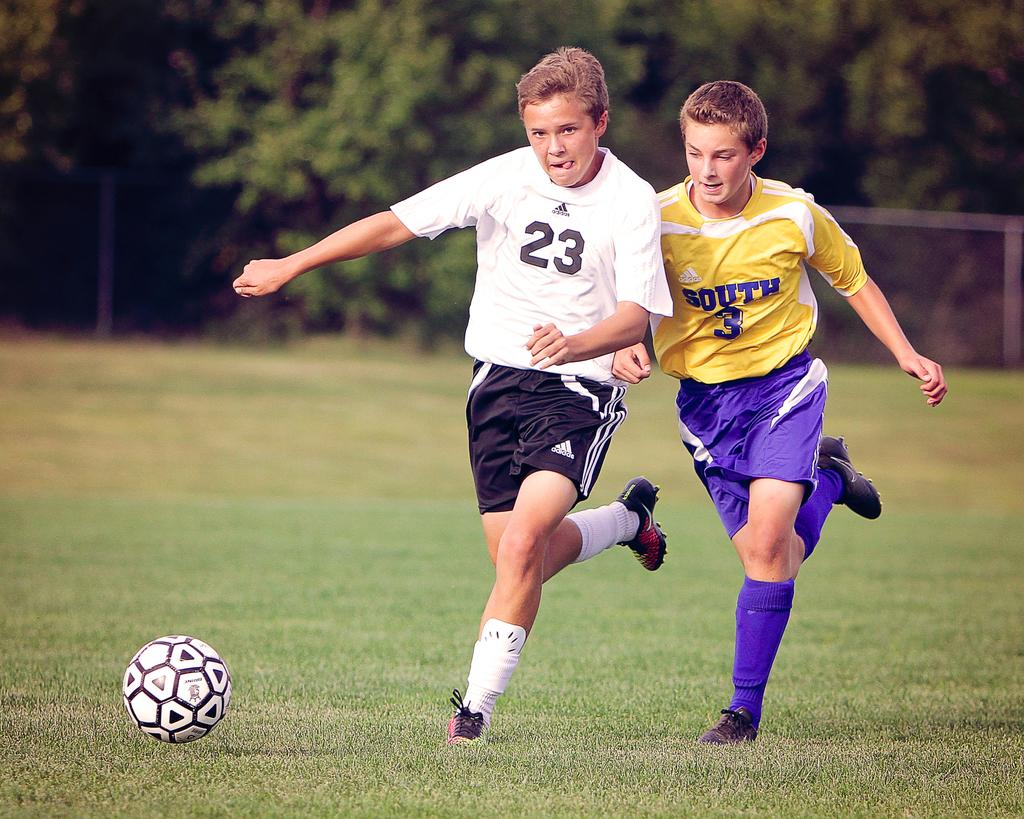<image>
Relay a brief, clear account of the picture shown. Tw toung footballers, one with a white top bearing the number 23, the other in yellow with South and 3 on his top, jostle for the ball. 